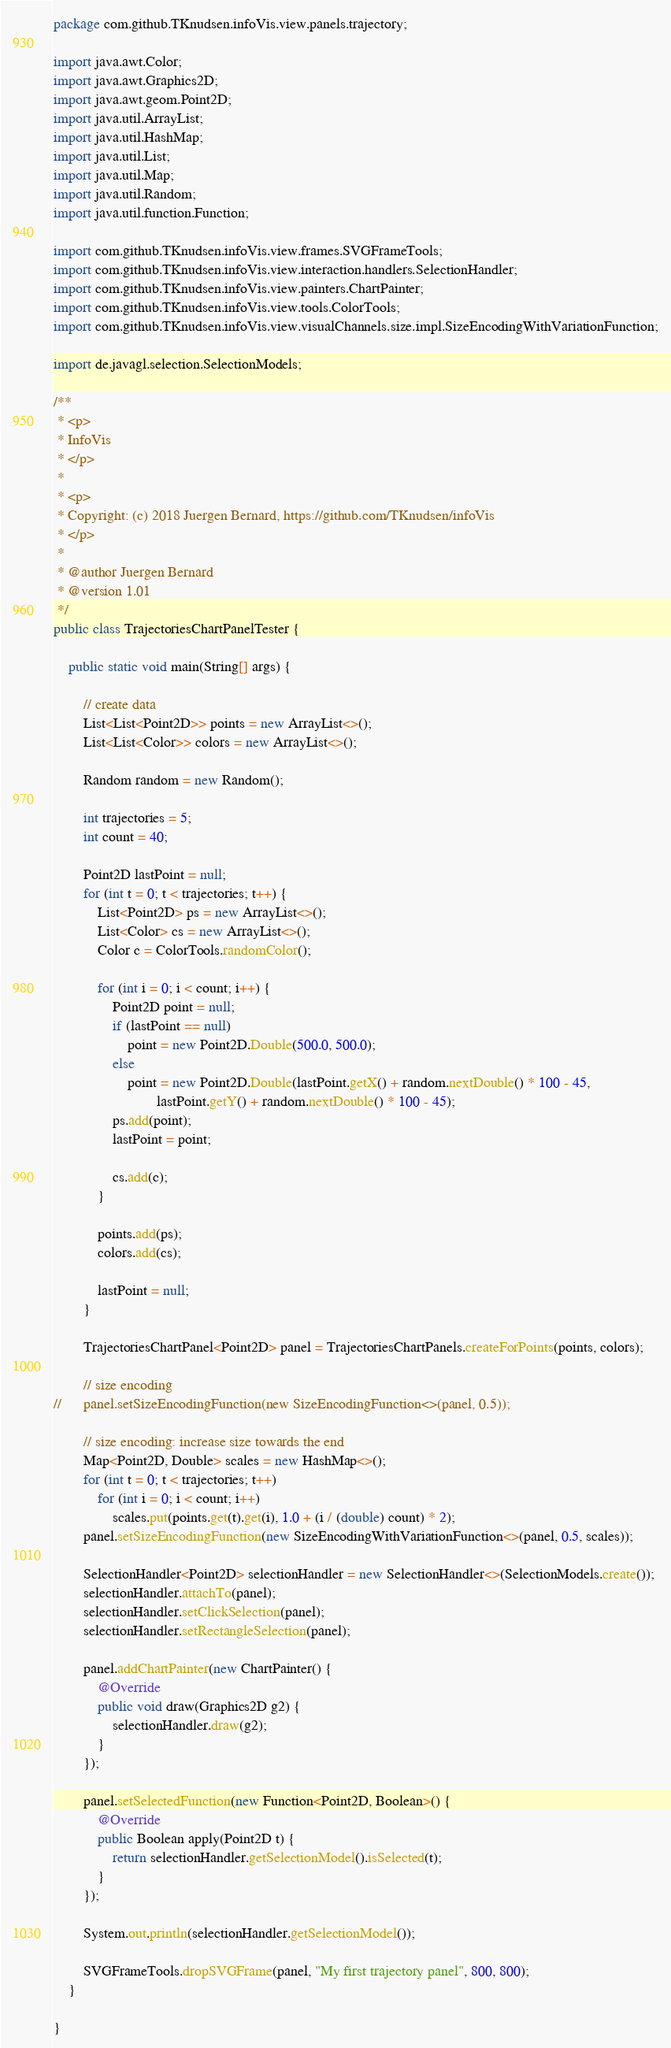<code> <loc_0><loc_0><loc_500><loc_500><_Java_>package com.github.TKnudsen.infoVis.view.panels.trajectory;

import java.awt.Color;
import java.awt.Graphics2D;
import java.awt.geom.Point2D;
import java.util.ArrayList;
import java.util.HashMap;
import java.util.List;
import java.util.Map;
import java.util.Random;
import java.util.function.Function;

import com.github.TKnudsen.infoVis.view.frames.SVGFrameTools;
import com.github.TKnudsen.infoVis.view.interaction.handlers.SelectionHandler;
import com.github.TKnudsen.infoVis.view.painters.ChartPainter;
import com.github.TKnudsen.infoVis.view.tools.ColorTools;
import com.github.TKnudsen.infoVis.view.visualChannels.size.impl.SizeEncodingWithVariationFunction;

import de.javagl.selection.SelectionModels;

/**
 * <p>
 * InfoVis
 * </p>
 * 
 * <p>
 * Copyright: (c) 2018 Juergen Bernard, https://github.com/TKnudsen/infoVis
 * </p>
 * 
 * @author Juergen Bernard
 * @version 1.01
 */
public class TrajectoriesChartPanelTester {

	public static void main(String[] args) {

		// create data
		List<List<Point2D>> points = new ArrayList<>();
		List<List<Color>> colors = new ArrayList<>();

		Random random = new Random();

		int trajectories = 5;
		int count = 40;

		Point2D lastPoint = null;
		for (int t = 0; t < trajectories; t++) {
			List<Point2D> ps = new ArrayList<>();
			List<Color> cs = new ArrayList<>();
			Color c = ColorTools.randomColor();

			for (int i = 0; i < count; i++) {
				Point2D point = null;
				if (lastPoint == null)
					point = new Point2D.Double(500.0, 500.0);
				else
					point = new Point2D.Double(lastPoint.getX() + random.nextDouble() * 100 - 45,
							lastPoint.getY() + random.nextDouble() * 100 - 45);
				ps.add(point);
				lastPoint = point;

				cs.add(c);
			}

			points.add(ps);
			colors.add(cs);

			lastPoint = null;
		}

		TrajectoriesChartPanel<Point2D> panel = TrajectoriesChartPanels.createForPoints(points, colors);

		// size encoding
//		panel.setSizeEncodingFunction(new SizeEncodingFunction<>(panel, 0.5));

		// size encoding: increase size towards the end
		Map<Point2D, Double> scales = new HashMap<>();
		for (int t = 0; t < trajectories; t++)
			for (int i = 0; i < count; i++)
				scales.put(points.get(t).get(i), 1.0 + (i / (double) count) * 2);
		panel.setSizeEncodingFunction(new SizeEncodingWithVariationFunction<>(panel, 0.5, scales));

		SelectionHandler<Point2D> selectionHandler = new SelectionHandler<>(SelectionModels.create());
		selectionHandler.attachTo(panel);
		selectionHandler.setClickSelection(panel);
		selectionHandler.setRectangleSelection(panel);

		panel.addChartPainter(new ChartPainter() {
			@Override
			public void draw(Graphics2D g2) {
				selectionHandler.draw(g2);
			}
		});

		panel.setSelectedFunction(new Function<Point2D, Boolean>() {
			@Override
			public Boolean apply(Point2D t) {
				return selectionHandler.getSelectionModel().isSelected(t);
			}
		});

		System.out.println(selectionHandler.getSelectionModel());

		SVGFrameTools.dropSVGFrame(panel, "My first trajectory panel", 800, 800);
	}

}
</code> 